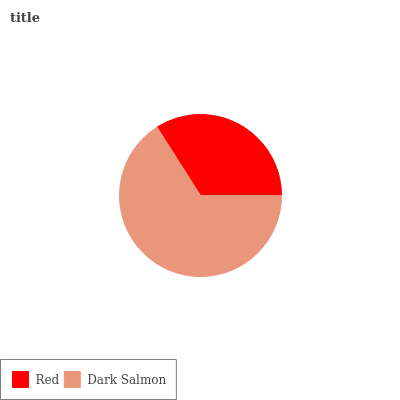Is Red the minimum?
Answer yes or no. Yes. Is Dark Salmon the maximum?
Answer yes or no. Yes. Is Dark Salmon the minimum?
Answer yes or no. No. Is Dark Salmon greater than Red?
Answer yes or no. Yes. Is Red less than Dark Salmon?
Answer yes or no. Yes. Is Red greater than Dark Salmon?
Answer yes or no. No. Is Dark Salmon less than Red?
Answer yes or no. No. Is Dark Salmon the high median?
Answer yes or no. Yes. Is Red the low median?
Answer yes or no. Yes. Is Red the high median?
Answer yes or no. No. Is Dark Salmon the low median?
Answer yes or no. No. 